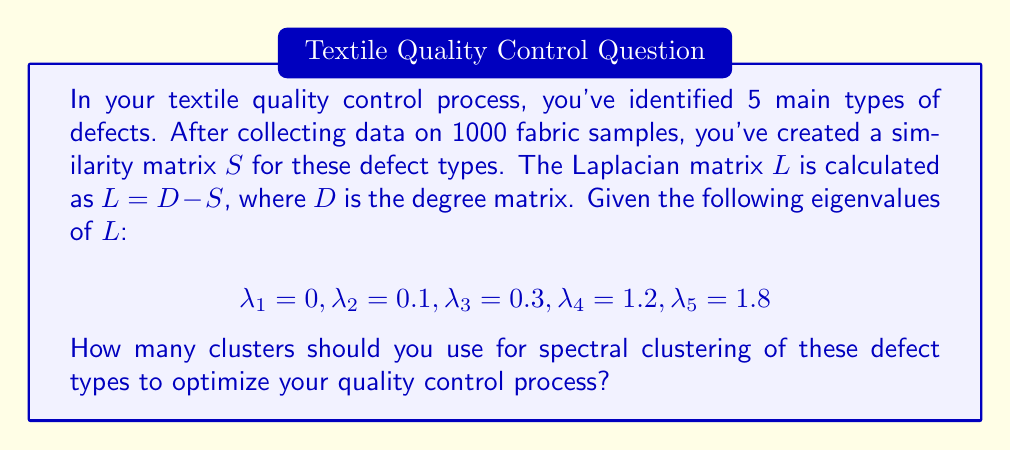Teach me how to tackle this problem. To determine the optimal number of clusters for spectral clustering, we'll follow these steps:

1) The number of clusters in spectral clustering is often determined by the eigengap heuristic. This involves finding the largest gap between consecutive eigenvalues when they are sorted in ascending order.

2) We already have the eigenvalues sorted:
   $$\lambda_1 = 0, \lambda_2 = 0.1, \lambda_3 = 0.3, \lambda_4 = 1.2, \lambda_5 = 1.8$$

3) Calculate the gaps between consecutive eigenvalues:
   $\lambda_2 - \lambda_1 = 0.1$
   $\lambda_3 - \lambda_2 = 0.2$
   $\lambda_4 - \lambda_3 = 0.9$
   $\lambda_5 - \lambda_4 = 0.6$

4) The largest gap is between $\lambda_3$ and $\lambda_4$, which is 0.9.

5) The number of clusters is determined by the index of this largest gap. Since the largest gap is between the 3rd and 4th eigenvalues, we should use 3 clusters.

This suggests that the 5 defect types can be effectively grouped into 3 clusters for optimized quality control processes.
Answer: 3 clusters 